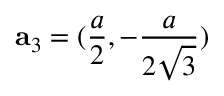<formula> <loc_0><loc_0><loc_500><loc_500>{ a } _ { 3 } = ( \frac { a } { 2 } , - \frac { a } { 2 \sqrt { 3 } } )</formula> 